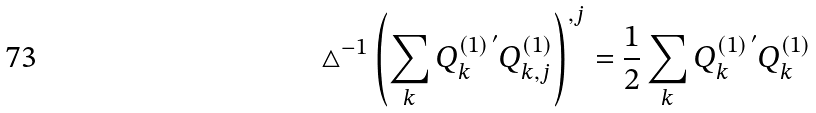Convert formula to latex. <formula><loc_0><loc_0><loc_500><loc_500>\triangle ^ { - 1 } \left ( \sum _ { k } Q ^ { ( 1 ) \, ^ { \prime } } _ { k } Q ^ { ( 1 ) } _ { k , j } \right ) ^ { , j } = \frac { 1 } { 2 } \sum _ { k } Q ^ { ( 1 ) \, ^ { \prime } } _ { k } Q ^ { ( 1 ) } _ { k }</formula> 